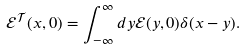<formula> <loc_0><loc_0><loc_500><loc_500>\mathcal { E } ^ { \mathcal { T } } ( x , 0 ) = \int _ { - \infty } ^ { \infty } d y \mathcal { E } ( y , 0 ) \delta ( x - y ) .</formula> 